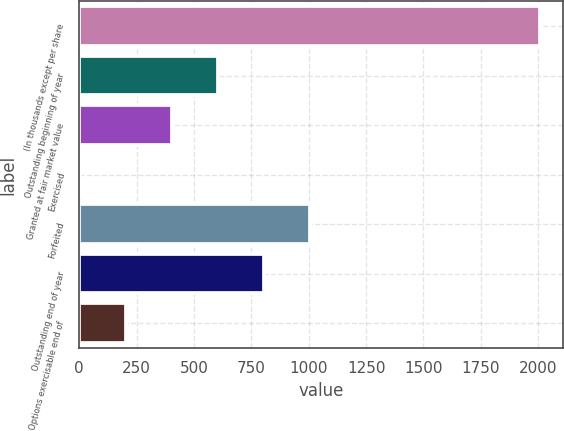Convert chart to OTSL. <chart><loc_0><loc_0><loc_500><loc_500><bar_chart><fcel>(In thousands except per share<fcel>Outstanding beginning of year<fcel>Granted at fair market value<fcel>Exercised<fcel>Forfeited<fcel>Outstanding end of year<fcel>Options exercisable end of<nl><fcel>2009<fcel>605.98<fcel>405.55<fcel>4.69<fcel>1006.84<fcel>806.41<fcel>205.12<nl></chart> 